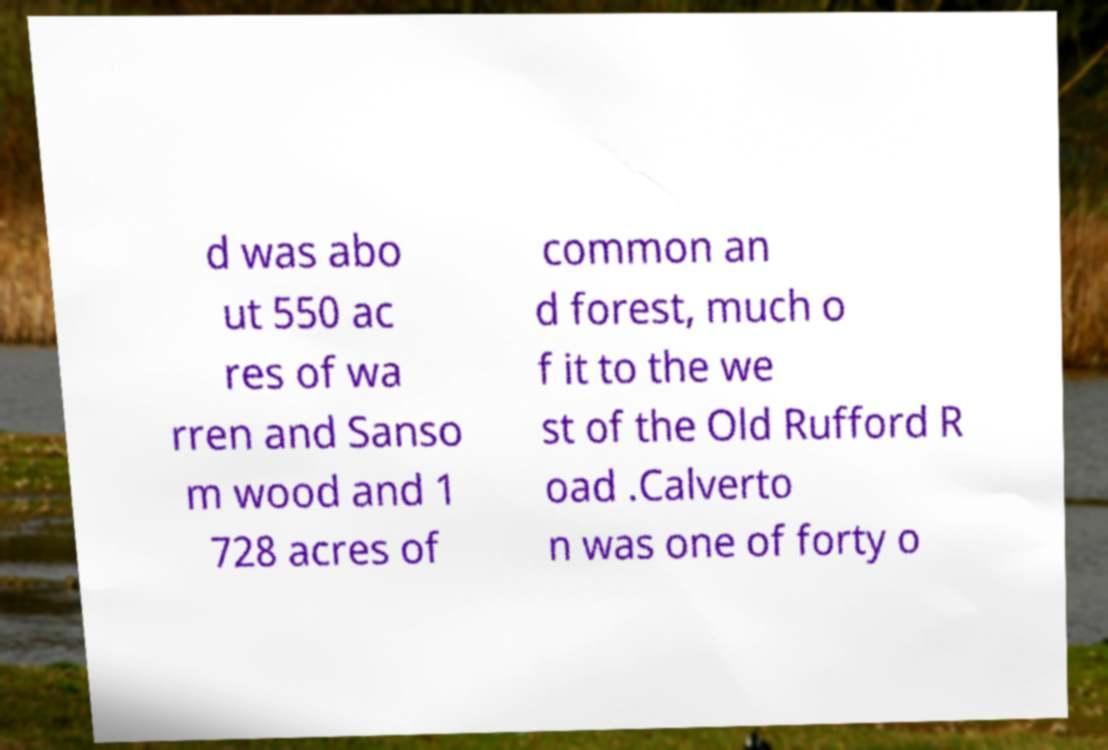For documentation purposes, I need the text within this image transcribed. Could you provide that? d was abo ut 550 ac res of wa rren and Sanso m wood and 1 728 acres of common an d forest, much o f it to the we st of the Old Rufford R oad .Calverto n was one of forty o 